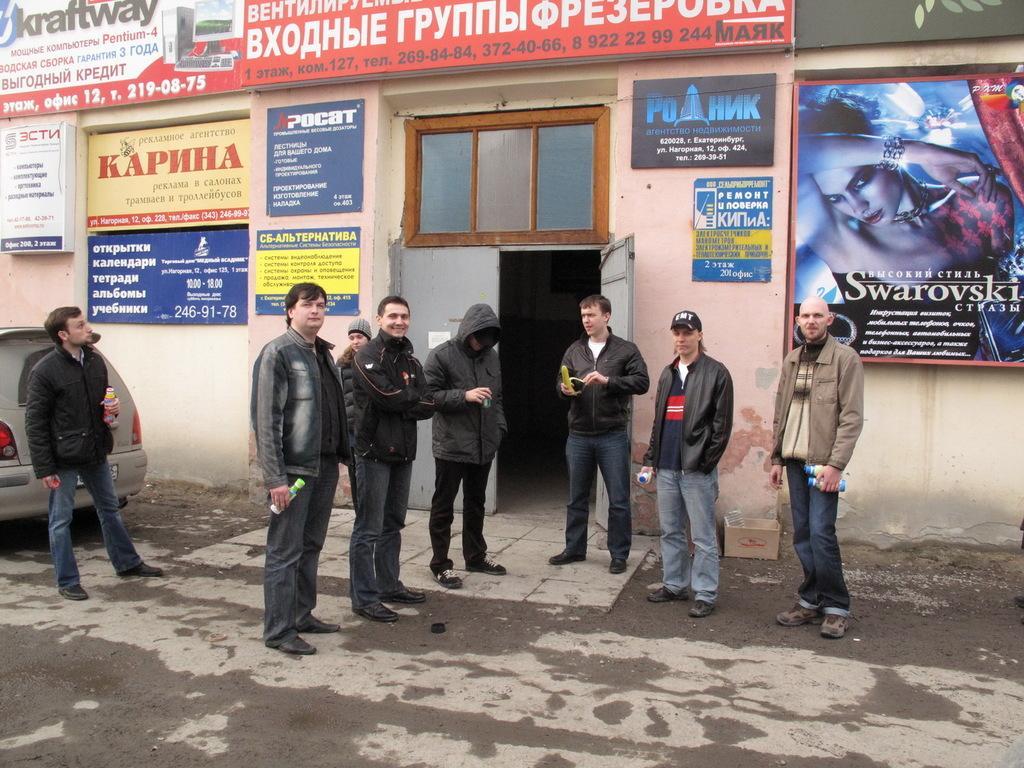Can you describe this image briefly? In this image, there is a road, there are some people standing and at the left side there is a car, there are some posters on the wall, at the middle there is a door. 